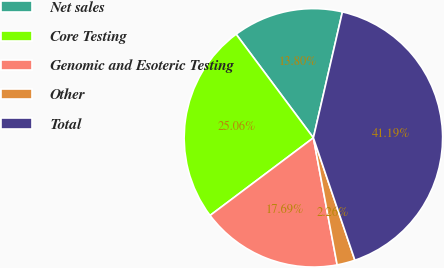<chart> <loc_0><loc_0><loc_500><loc_500><pie_chart><fcel>Net sales<fcel>Core Testing<fcel>Genomic and Esoteric Testing<fcel>Other<fcel>Total<nl><fcel>13.8%<fcel>25.06%<fcel>17.69%<fcel>2.26%<fcel>41.19%<nl></chart> 